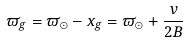Convert formula to latex. <formula><loc_0><loc_0><loc_500><loc_500>\varpi _ { g } = \varpi _ { \odot } - x _ { g } = \varpi _ { \odot } + \frac { v } { 2 B }</formula> 